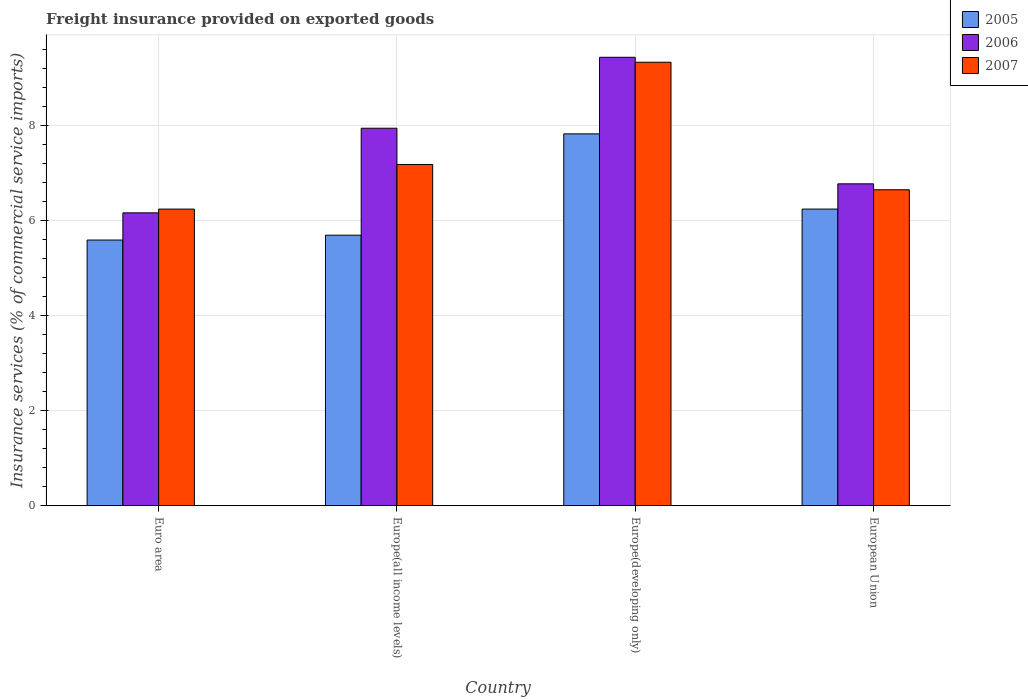How many different coloured bars are there?
Provide a succinct answer. 3. Are the number of bars on each tick of the X-axis equal?
Your answer should be compact. Yes. How many bars are there on the 2nd tick from the left?
Offer a terse response. 3. How many bars are there on the 2nd tick from the right?
Provide a succinct answer. 3. What is the label of the 4th group of bars from the left?
Give a very brief answer. European Union. What is the freight insurance provided on exported goods in 2005 in Europe(developing only)?
Make the answer very short. 7.83. Across all countries, what is the maximum freight insurance provided on exported goods in 2007?
Offer a very short reply. 9.33. Across all countries, what is the minimum freight insurance provided on exported goods in 2005?
Provide a short and direct response. 5.59. In which country was the freight insurance provided on exported goods in 2005 maximum?
Offer a terse response. Europe(developing only). In which country was the freight insurance provided on exported goods in 2005 minimum?
Your answer should be very brief. Euro area. What is the total freight insurance provided on exported goods in 2005 in the graph?
Provide a short and direct response. 25.35. What is the difference between the freight insurance provided on exported goods in 2007 in Europe(developing only) and that in European Union?
Provide a succinct answer. 2.68. What is the difference between the freight insurance provided on exported goods in 2006 in European Union and the freight insurance provided on exported goods in 2007 in Europe(all income levels)?
Give a very brief answer. -0.41. What is the average freight insurance provided on exported goods in 2007 per country?
Your answer should be compact. 7.35. What is the difference between the freight insurance provided on exported goods of/in 2006 and freight insurance provided on exported goods of/in 2007 in Europe(all income levels)?
Provide a short and direct response. 0.76. In how many countries, is the freight insurance provided on exported goods in 2006 greater than 7.2 %?
Give a very brief answer. 2. What is the ratio of the freight insurance provided on exported goods in 2007 in Europe(all income levels) to that in Europe(developing only)?
Your answer should be compact. 0.77. Is the difference between the freight insurance provided on exported goods in 2006 in Europe(all income levels) and Europe(developing only) greater than the difference between the freight insurance provided on exported goods in 2007 in Europe(all income levels) and Europe(developing only)?
Your answer should be very brief. Yes. What is the difference between the highest and the second highest freight insurance provided on exported goods in 2006?
Provide a short and direct response. 2.66. What is the difference between the highest and the lowest freight insurance provided on exported goods in 2007?
Make the answer very short. 3.09. Is the sum of the freight insurance provided on exported goods in 2007 in Euro area and Europe(all income levels) greater than the maximum freight insurance provided on exported goods in 2005 across all countries?
Make the answer very short. Yes. Is it the case that in every country, the sum of the freight insurance provided on exported goods in 2007 and freight insurance provided on exported goods in 2005 is greater than the freight insurance provided on exported goods in 2006?
Ensure brevity in your answer.  Yes. How many bars are there?
Offer a very short reply. 12. How many countries are there in the graph?
Make the answer very short. 4. What is the difference between two consecutive major ticks on the Y-axis?
Provide a short and direct response. 2. Does the graph contain grids?
Make the answer very short. Yes. What is the title of the graph?
Your answer should be very brief. Freight insurance provided on exported goods. What is the label or title of the X-axis?
Provide a short and direct response. Country. What is the label or title of the Y-axis?
Your answer should be compact. Insurance services (% of commercial service imports). What is the Insurance services (% of commercial service imports) of 2005 in Euro area?
Keep it short and to the point. 5.59. What is the Insurance services (% of commercial service imports) of 2006 in Euro area?
Offer a very short reply. 6.16. What is the Insurance services (% of commercial service imports) of 2007 in Euro area?
Provide a short and direct response. 6.24. What is the Insurance services (% of commercial service imports) of 2005 in Europe(all income levels)?
Your answer should be compact. 5.69. What is the Insurance services (% of commercial service imports) of 2006 in Europe(all income levels)?
Keep it short and to the point. 7.94. What is the Insurance services (% of commercial service imports) in 2007 in Europe(all income levels)?
Offer a terse response. 7.18. What is the Insurance services (% of commercial service imports) in 2005 in Europe(developing only)?
Provide a short and direct response. 7.83. What is the Insurance services (% of commercial service imports) of 2006 in Europe(developing only)?
Keep it short and to the point. 9.44. What is the Insurance services (% of commercial service imports) in 2007 in Europe(developing only)?
Make the answer very short. 9.33. What is the Insurance services (% of commercial service imports) of 2005 in European Union?
Give a very brief answer. 6.24. What is the Insurance services (% of commercial service imports) in 2006 in European Union?
Make the answer very short. 6.77. What is the Insurance services (% of commercial service imports) in 2007 in European Union?
Keep it short and to the point. 6.65. Across all countries, what is the maximum Insurance services (% of commercial service imports) of 2005?
Your answer should be very brief. 7.83. Across all countries, what is the maximum Insurance services (% of commercial service imports) in 2006?
Offer a terse response. 9.44. Across all countries, what is the maximum Insurance services (% of commercial service imports) in 2007?
Give a very brief answer. 9.33. Across all countries, what is the minimum Insurance services (% of commercial service imports) of 2005?
Your answer should be very brief. 5.59. Across all countries, what is the minimum Insurance services (% of commercial service imports) of 2006?
Provide a short and direct response. 6.16. Across all countries, what is the minimum Insurance services (% of commercial service imports) in 2007?
Your answer should be very brief. 6.24. What is the total Insurance services (% of commercial service imports) of 2005 in the graph?
Offer a terse response. 25.35. What is the total Insurance services (% of commercial service imports) in 2006 in the graph?
Keep it short and to the point. 30.32. What is the total Insurance services (% of commercial service imports) of 2007 in the graph?
Your answer should be very brief. 29.41. What is the difference between the Insurance services (% of commercial service imports) in 2005 in Euro area and that in Europe(all income levels)?
Offer a terse response. -0.1. What is the difference between the Insurance services (% of commercial service imports) of 2006 in Euro area and that in Europe(all income levels)?
Ensure brevity in your answer.  -1.78. What is the difference between the Insurance services (% of commercial service imports) in 2007 in Euro area and that in Europe(all income levels)?
Offer a terse response. -0.94. What is the difference between the Insurance services (% of commercial service imports) of 2005 in Euro area and that in Europe(developing only)?
Provide a succinct answer. -2.23. What is the difference between the Insurance services (% of commercial service imports) of 2006 in Euro area and that in Europe(developing only)?
Provide a short and direct response. -3.27. What is the difference between the Insurance services (% of commercial service imports) in 2007 in Euro area and that in Europe(developing only)?
Offer a terse response. -3.09. What is the difference between the Insurance services (% of commercial service imports) of 2005 in Euro area and that in European Union?
Provide a succinct answer. -0.65. What is the difference between the Insurance services (% of commercial service imports) in 2006 in Euro area and that in European Union?
Provide a short and direct response. -0.61. What is the difference between the Insurance services (% of commercial service imports) of 2007 in Euro area and that in European Union?
Make the answer very short. -0.41. What is the difference between the Insurance services (% of commercial service imports) in 2005 in Europe(all income levels) and that in Europe(developing only)?
Give a very brief answer. -2.13. What is the difference between the Insurance services (% of commercial service imports) in 2006 in Europe(all income levels) and that in Europe(developing only)?
Your answer should be compact. -1.49. What is the difference between the Insurance services (% of commercial service imports) in 2007 in Europe(all income levels) and that in Europe(developing only)?
Your response must be concise. -2.15. What is the difference between the Insurance services (% of commercial service imports) of 2005 in Europe(all income levels) and that in European Union?
Provide a succinct answer. -0.55. What is the difference between the Insurance services (% of commercial service imports) of 2006 in Europe(all income levels) and that in European Union?
Ensure brevity in your answer.  1.17. What is the difference between the Insurance services (% of commercial service imports) of 2007 in Europe(all income levels) and that in European Union?
Offer a terse response. 0.53. What is the difference between the Insurance services (% of commercial service imports) in 2005 in Europe(developing only) and that in European Union?
Provide a short and direct response. 1.58. What is the difference between the Insurance services (% of commercial service imports) in 2006 in Europe(developing only) and that in European Union?
Give a very brief answer. 2.66. What is the difference between the Insurance services (% of commercial service imports) of 2007 in Europe(developing only) and that in European Union?
Your answer should be compact. 2.68. What is the difference between the Insurance services (% of commercial service imports) in 2005 in Euro area and the Insurance services (% of commercial service imports) in 2006 in Europe(all income levels)?
Offer a very short reply. -2.35. What is the difference between the Insurance services (% of commercial service imports) of 2005 in Euro area and the Insurance services (% of commercial service imports) of 2007 in Europe(all income levels)?
Your response must be concise. -1.59. What is the difference between the Insurance services (% of commercial service imports) of 2006 in Euro area and the Insurance services (% of commercial service imports) of 2007 in Europe(all income levels)?
Ensure brevity in your answer.  -1.02. What is the difference between the Insurance services (% of commercial service imports) in 2005 in Euro area and the Insurance services (% of commercial service imports) in 2006 in Europe(developing only)?
Give a very brief answer. -3.85. What is the difference between the Insurance services (% of commercial service imports) in 2005 in Euro area and the Insurance services (% of commercial service imports) in 2007 in Europe(developing only)?
Make the answer very short. -3.74. What is the difference between the Insurance services (% of commercial service imports) in 2006 in Euro area and the Insurance services (% of commercial service imports) in 2007 in Europe(developing only)?
Make the answer very short. -3.17. What is the difference between the Insurance services (% of commercial service imports) of 2005 in Euro area and the Insurance services (% of commercial service imports) of 2006 in European Union?
Provide a short and direct response. -1.18. What is the difference between the Insurance services (% of commercial service imports) of 2005 in Euro area and the Insurance services (% of commercial service imports) of 2007 in European Union?
Give a very brief answer. -1.06. What is the difference between the Insurance services (% of commercial service imports) of 2006 in Euro area and the Insurance services (% of commercial service imports) of 2007 in European Union?
Offer a terse response. -0.49. What is the difference between the Insurance services (% of commercial service imports) of 2005 in Europe(all income levels) and the Insurance services (% of commercial service imports) of 2006 in Europe(developing only)?
Provide a succinct answer. -3.74. What is the difference between the Insurance services (% of commercial service imports) in 2005 in Europe(all income levels) and the Insurance services (% of commercial service imports) in 2007 in Europe(developing only)?
Provide a succinct answer. -3.64. What is the difference between the Insurance services (% of commercial service imports) of 2006 in Europe(all income levels) and the Insurance services (% of commercial service imports) of 2007 in Europe(developing only)?
Keep it short and to the point. -1.39. What is the difference between the Insurance services (% of commercial service imports) of 2005 in Europe(all income levels) and the Insurance services (% of commercial service imports) of 2006 in European Union?
Your response must be concise. -1.08. What is the difference between the Insurance services (% of commercial service imports) of 2005 in Europe(all income levels) and the Insurance services (% of commercial service imports) of 2007 in European Union?
Your answer should be compact. -0.96. What is the difference between the Insurance services (% of commercial service imports) in 2006 in Europe(all income levels) and the Insurance services (% of commercial service imports) in 2007 in European Union?
Your answer should be compact. 1.29. What is the difference between the Insurance services (% of commercial service imports) of 2005 in Europe(developing only) and the Insurance services (% of commercial service imports) of 2006 in European Union?
Provide a short and direct response. 1.05. What is the difference between the Insurance services (% of commercial service imports) of 2005 in Europe(developing only) and the Insurance services (% of commercial service imports) of 2007 in European Union?
Offer a terse response. 1.18. What is the difference between the Insurance services (% of commercial service imports) of 2006 in Europe(developing only) and the Insurance services (% of commercial service imports) of 2007 in European Union?
Make the answer very short. 2.79. What is the average Insurance services (% of commercial service imports) of 2005 per country?
Your response must be concise. 6.34. What is the average Insurance services (% of commercial service imports) of 2006 per country?
Keep it short and to the point. 7.58. What is the average Insurance services (% of commercial service imports) in 2007 per country?
Your response must be concise. 7.35. What is the difference between the Insurance services (% of commercial service imports) of 2005 and Insurance services (% of commercial service imports) of 2006 in Euro area?
Make the answer very short. -0.57. What is the difference between the Insurance services (% of commercial service imports) in 2005 and Insurance services (% of commercial service imports) in 2007 in Euro area?
Make the answer very short. -0.65. What is the difference between the Insurance services (% of commercial service imports) of 2006 and Insurance services (% of commercial service imports) of 2007 in Euro area?
Offer a very short reply. -0.08. What is the difference between the Insurance services (% of commercial service imports) of 2005 and Insurance services (% of commercial service imports) of 2006 in Europe(all income levels)?
Ensure brevity in your answer.  -2.25. What is the difference between the Insurance services (% of commercial service imports) in 2005 and Insurance services (% of commercial service imports) in 2007 in Europe(all income levels)?
Your response must be concise. -1.49. What is the difference between the Insurance services (% of commercial service imports) in 2006 and Insurance services (% of commercial service imports) in 2007 in Europe(all income levels)?
Ensure brevity in your answer.  0.76. What is the difference between the Insurance services (% of commercial service imports) in 2005 and Insurance services (% of commercial service imports) in 2006 in Europe(developing only)?
Offer a terse response. -1.61. What is the difference between the Insurance services (% of commercial service imports) in 2005 and Insurance services (% of commercial service imports) in 2007 in Europe(developing only)?
Your answer should be very brief. -1.51. What is the difference between the Insurance services (% of commercial service imports) of 2006 and Insurance services (% of commercial service imports) of 2007 in Europe(developing only)?
Keep it short and to the point. 0.1. What is the difference between the Insurance services (% of commercial service imports) of 2005 and Insurance services (% of commercial service imports) of 2006 in European Union?
Offer a terse response. -0.53. What is the difference between the Insurance services (% of commercial service imports) in 2005 and Insurance services (% of commercial service imports) in 2007 in European Union?
Give a very brief answer. -0.41. What is the difference between the Insurance services (% of commercial service imports) of 2006 and Insurance services (% of commercial service imports) of 2007 in European Union?
Your answer should be very brief. 0.12. What is the ratio of the Insurance services (% of commercial service imports) of 2005 in Euro area to that in Europe(all income levels)?
Give a very brief answer. 0.98. What is the ratio of the Insurance services (% of commercial service imports) of 2006 in Euro area to that in Europe(all income levels)?
Your answer should be compact. 0.78. What is the ratio of the Insurance services (% of commercial service imports) in 2007 in Euro area to that in Europe(all income levels)?
Your response must be concise. 0.87. What is the ratio of the Insurance services (% of commercial service imports) of 2005 in Euro area to that in Europe(developing only)?
Offer a very short reply. 0.71. What is the ratio of the Insurance services (% of commercial service imports) in 2006 in Euro area to that in Europe(developing only)?
Make the answer very short. 0.65. What is the ratio of the Insurance services (% of commercial service imports) of 2007 in Euro area to that in Europe(developing only)?
Ensure brevity in your answer.  0.67. What is the ratio of the Insurance services (% of commercial service imports) in 2005 in Euro area to that in European Union?
Provide a short and direct response. 0.9. What is the ratio of the Insurance services (% of commercial service imports) of 2006 in Euro area to that in European Union?
Give a very brief answer. 0.91. What is the ratio of the Insurance services (% of commercial service imports) of 2007 in Euro area to that in European Union?
Give a very brief answer. 0.94. What is the ratio of the Insurance services (% of commercial service imports) in 2005 in Europe(all income levels) to that in Europe(developing only)?
Provide a succinct answer. 0.73. What is the ratio of the Insurance services (% of commercial service imports) in 2006 in Europe(all income levels) to that in Europe(developing only)?
Your answer should be compact. 0.84. What is the ratio of the Insurance services (% of commercial service imports) in 2007 in Europe(all income levels) to that in Europe(developing only)?
Your answer should be very brief. 0.77. What is the ratio of the Insurance services (% of commercial service imports) of 2005 in Europe(all income levels) to that in European Union?
Provide a short and direct response. 0.91. What is the ratio of the Insurance services (% of commercial service imports) in 2006 in Europe(all income levels) to that in European Union?
Ensure brevity in your answer.  1.17. What is the ratio of the Insurance services (% of commercial service imports) in 2007 in Europe(all income levels) to that in European Union?
Keep it short and to the point. 1.08. What is the ratio of the Insurance services (% of commercial service imports) in 2005 in Europe(developing only) to that in European Union?
Your answer should be compact. 1.25. What is the ratio of the Insurance services (% of commercial service imports) of 2006 in Europe(developing only) to that in European Union?
Ensure brevity in your answer.  1.39. What is the ratio of the Insurance services (% of commercial service imports) of 2007 in Europe(developing only) to that in European Union?
Offer a terse response. 1.4. What is the difference between the highest and the second highest Insurance services (% of commercial service imports) in 2005?
Your answer should be compact. 1.58. What is the difference between the highest and the second highest Insurance services (% of commercial service imports) of 2006?
Make the answer very short. 1.49. What is the difference between the highest and the second highest Insurance services (% of commercial service imports) of 2007?
Provide a short and direct response. 2.15. What is the difference between the highest and the lowest Insurance services (% of commercial service imports) of 2005?
Provide a short and direct response. 2.23. What is the difference between the highest and the lowest Insurance services (% of commercial service imports) of 2006?
Keep it short and to the point. 3.27. What is the difference between the highest and the lowest Insurance services (% of commercial service imports) of 2007?
Provide a short and direct response. 3.09. 